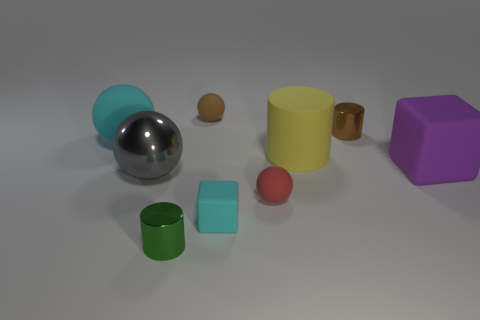Subtract all small green cylinders. How many cylinders are left? 2 Subtract 1 cylinders. How many cylinders are left? 2 Subtract all cyan spheres. How many spheres are left? 3 Subtract all cylinders. How many objects are left? 6 Add 1 small green shiny balls. How many objects exist? 10 Add 8 tiny green shiny cylinders. How many tiny green shiny cylinders exist? 9 Subtract 0 yellow balls. How many objects are left? 9 Subtract all purple cylinders. Subtract all red blocks. How many cylinders are left? 3 Subtract all tiny things. Subtract all big cyan rubber balls. How many objects are left? 3 Add 5 purple things. How many purple things are left? 6 